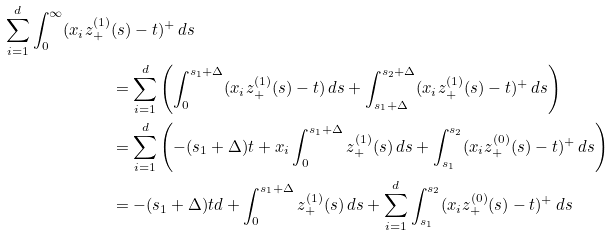Convert formula to latex. <formula><loc_0><loc_0><loc_500><loc_500>\sum _ { i = 1 } ^ { d } \int _ { 0 } ^ { \infty } ( x _ { i } z _ { + } ^ { ( 1 ) } & ( s ) - t ) ^ { + } \, d s \\ & = \sum _ { i = 1 } ^ { d } \left ( \int _ { 0 } ^ { s _ { 1 } + \Delta } ( x _ { i } z _ { + } ^ { ( 1 ) } ( s ) - t ) \, d s + \int _ { s _ { 1 } + \Delta } ^ { s _ { 2 } + \Delta } ( x _ { i } z _ { + } ^ { ( 1 ) } ( s ) - t ) ^ { + } \, d s \right ) \\ & = \sum _ { i = 1 } ^ { d } \left ( - ( s _ { 1 } + \Delta ) t + x _ { i } \int _ { 0 } ^ { s _ { 1 } + \Delta } z _ { + } ^ { ( 1 ) } ( s ) \, d s + \int _ { s _ { 1 } } ^ { s _ { 2 } } ( x _ { i } z _ { + } ^ { ( 0 ) } ( s ) - t ) ^ { + } \, d s \right ) \\ & = - ( s _ { 1 } + \Delta ) t d + \int _ { 0 } ^ { s _ { 1 } + \Delta } z _ { + } ^ { ( 1 ) } ( s ) \, d s + \sum _ { i = 1 } ^ { d } \int _ { s _ { 1 } } ^ { s _ { 2 } } ( x _ { i } z _ { + } ^ { ( 0 ) } ( s ) - t ) ^ { + } \, d s</formula> 